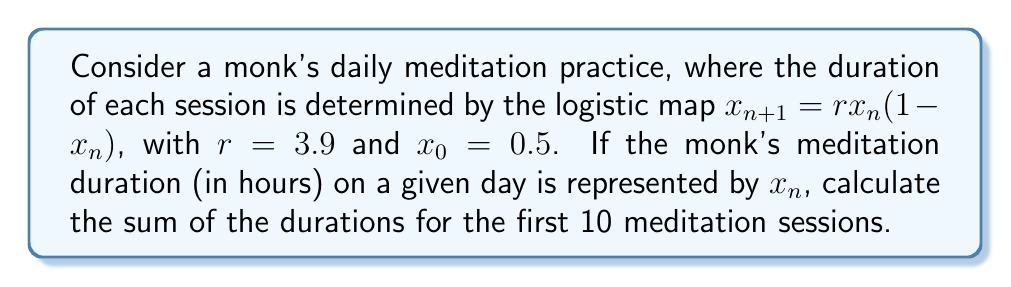Can you solve this math problem? Let's approach this step-by-step:

1) We start with the logistic map equation: $x_{n+1} = rx_n(1-x_n)$
   Where $r = 3.9$ and $x_0 = 0.5$

2) Let's calculate the first 10 values:

   $x_1 = 3.9 * 0.5 * (1-0.5) = 0.975$
   
   $x_2 = 3.9 * 0.975 * (1-0.975) = 0.0950625$
   
   $x_3 = 3.9 * 0.0950625 * (1-0.0950625) = 0.3352699219$
   
   $x_4 = 3.9 * 0.3352699219 * (1-0.3352699219) = 0.8681518555$
   
   $x_5 = 3.9 * 0.8681518555 * (1-0.8681518555) = 0.4459333896$
   
   $x_6 = 3.9 * 0.4459333896 * (1-0.4459333896) = 0.9630098572$
   
   $x_7 = 3.9 * 0.9630098572 * (1-0.9630098572) = 0.1397485669$
   
   $x_8 = 3.9 * 0.1397485669 * (1-0.1397485669) = 0.4685989655$
   
   $x_9 = 3.9 * 0.4685989655 * (1-0.4685989655) = 0.9714050293$
   
   $x_{10} = 3.9 * 0.9714050293 * (1-0.9714050293) = 0.1081635071$

3) Now, we sum all these values:

   $S = x_0 + x_1 + x_2 + x_3 + x_4 + x_5 + x_6 + x_7 + x_8 + x_9 + x_{10}$

4) Substituting the values:

   $S = 0.5 + 0.975 + 0.0950625 + 0.3352699219 + 0.8681518555 + 0.4459333896 + 0.9630098572 + 0.1397485669 + 0.4685989655 + 0.9714050293 + 0.1081635071$

5) Adding these up:

   $S \approx 5.8703436$

This sum represents the total duration of meditation in hours over the first 10 sessions.
Answer: $5.8703436$ hours 